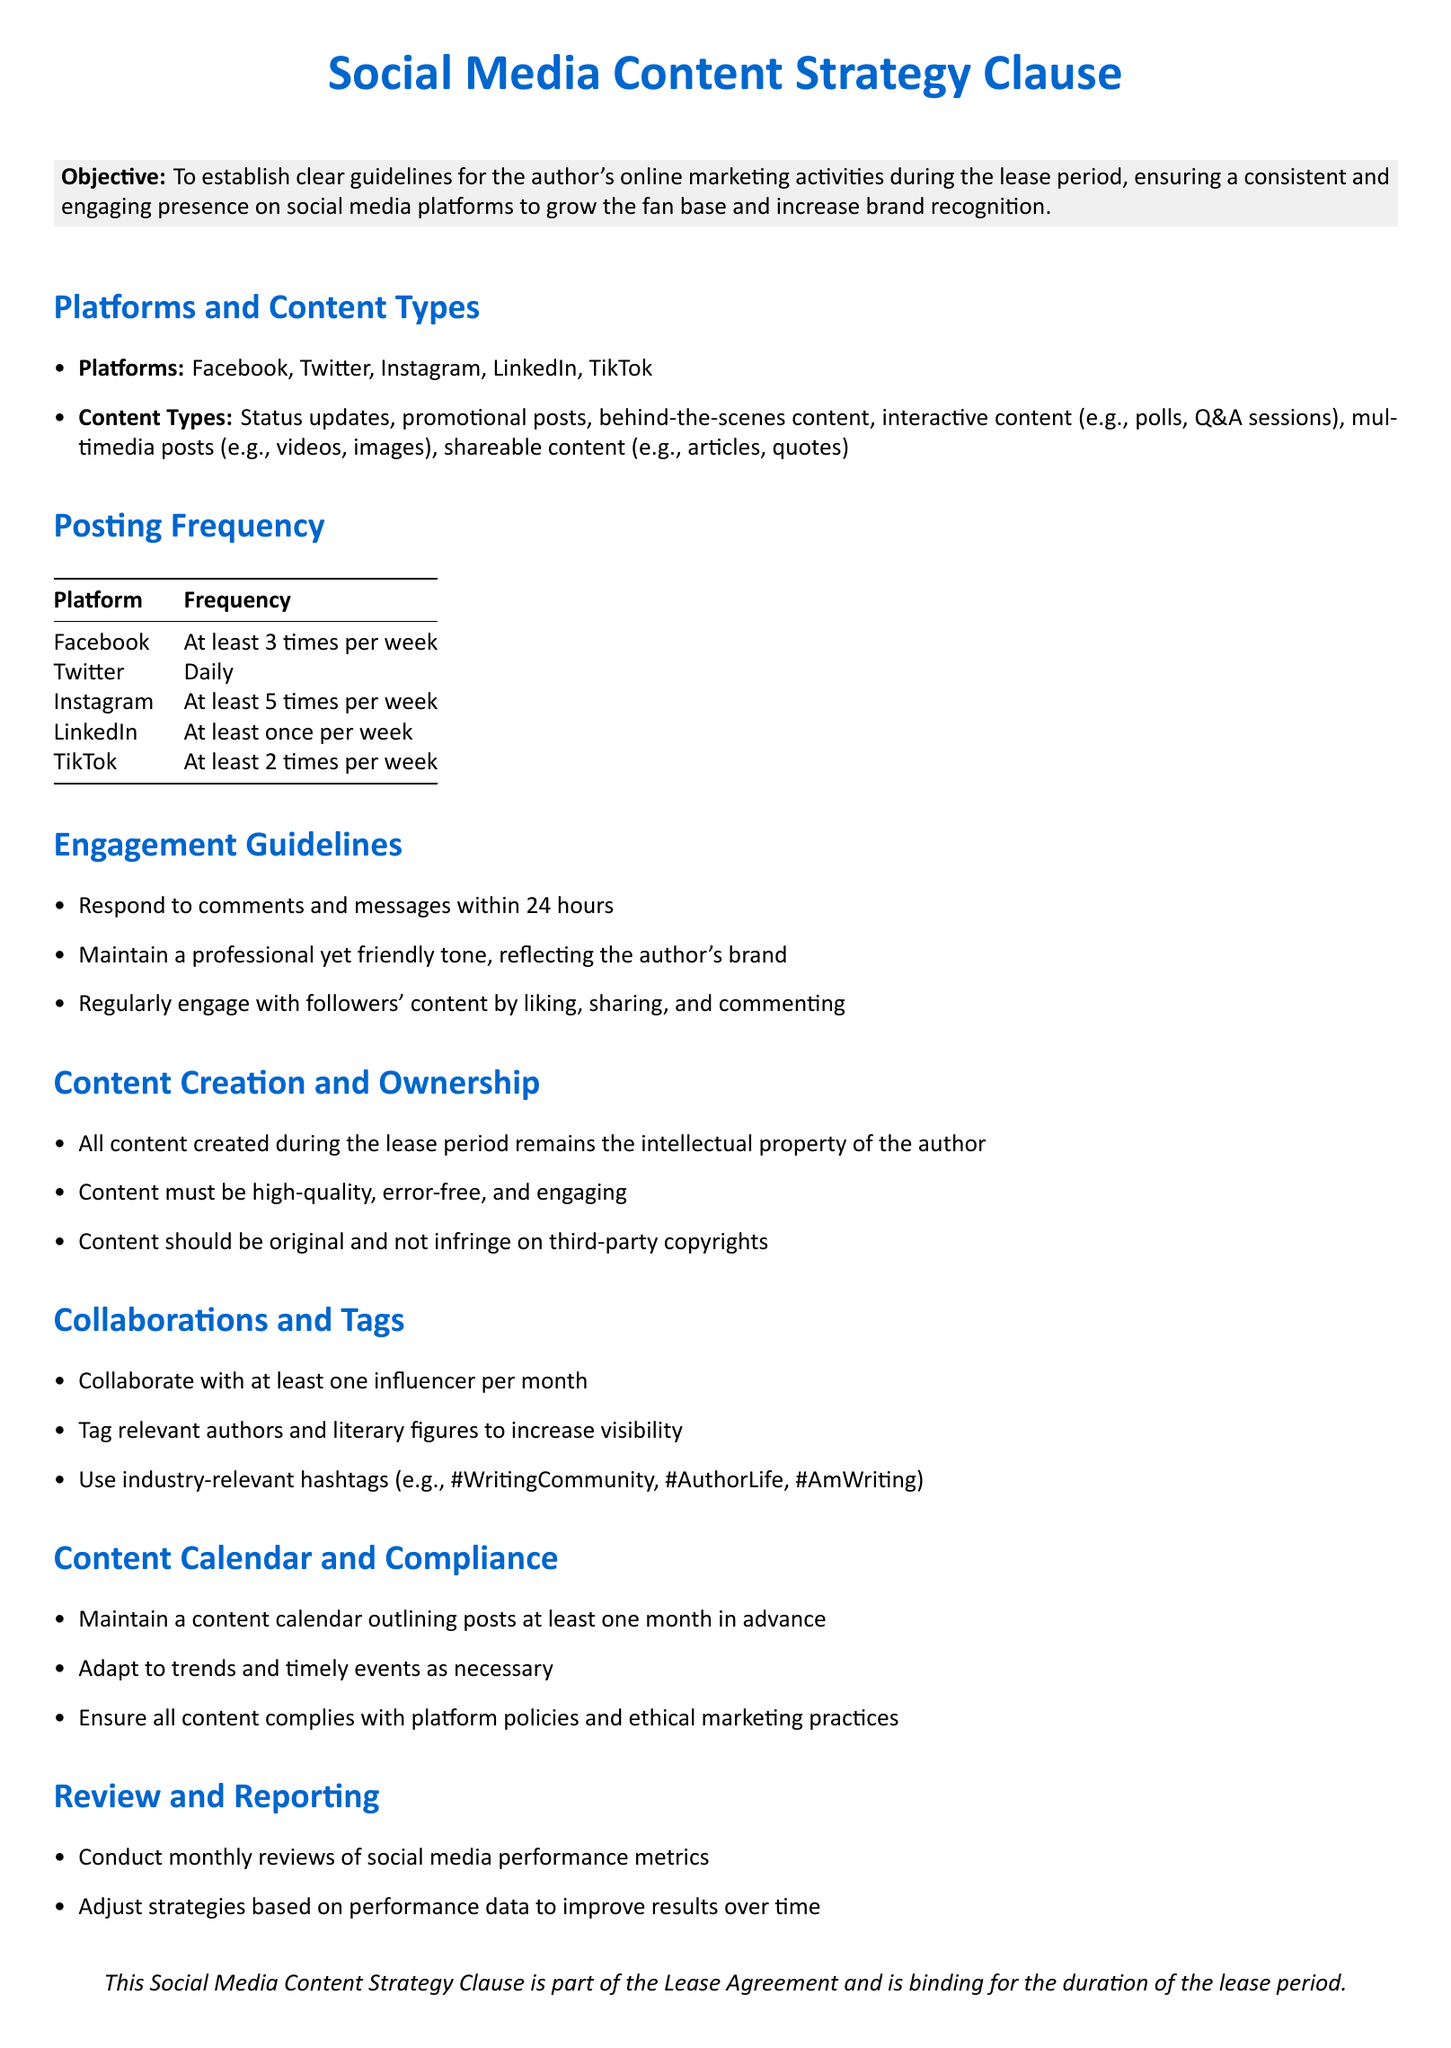What platforms are included in the strategy? The platforms listed in the document are the specific social media channels where the author will be active during the lease.
Answer: Facebook, Twitter, Instagram, LinkedIn, TikTok What is the posting frequency for Twitter? The frequency for Twitter is specified in a tabular format for clarity, indicating how often the author should post on that platform.
Answer: Daily How often should the author collaborate with influencers? This is outlined in the collaboration section, specifying how frequently such interactions are to take place.
Answer: At least once per month What is required for content quality? Content quality requirements are mentioned in the content creation section, focusing on the standards expected for engagement.
Answer: High-quality, error-free, and engaging How long is the response time for comments? The engagement guidelines specify timeframes for interacting with followers, indicating expectations for responsiveness.
Answer: Within 24 hours Which type of content must be original? Content guidelines specify types of content that must be unique and refrain from copyright infringement.
Answer: All content created during the lease period What should the content calendar outline? The content calendar's purpose and requirements are detailed, emphasizing its role in planning posts.
Answer: Posts at least one month in advance What is the compliance requirement for content? The compliance section emphasizes the importance of adhering to guidelines and policies for content.
Answer: Ensure all content complies with platform policies and ethical marketing practices What type of tone should be maintained in engagement? The engagement guidelines provide expectations for the tone used when interacting with followers and other users.
Answer: Professional yet friendly 